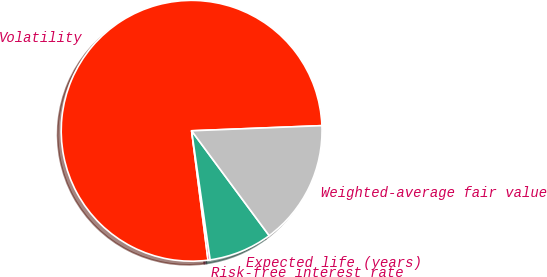Convert chart to OTSL. <chart><loc_0><loc_0><loc_500><loc_500><pie_chart><fcel>Volatility<fcel>Risk-free interest rate<fcel>Expected life (years)<fcel>Weighted-average fair value<nl><fcel>76.38%<fcel>0.26%<fcel>7.87%<fcel>15.49%<nl></chart> 